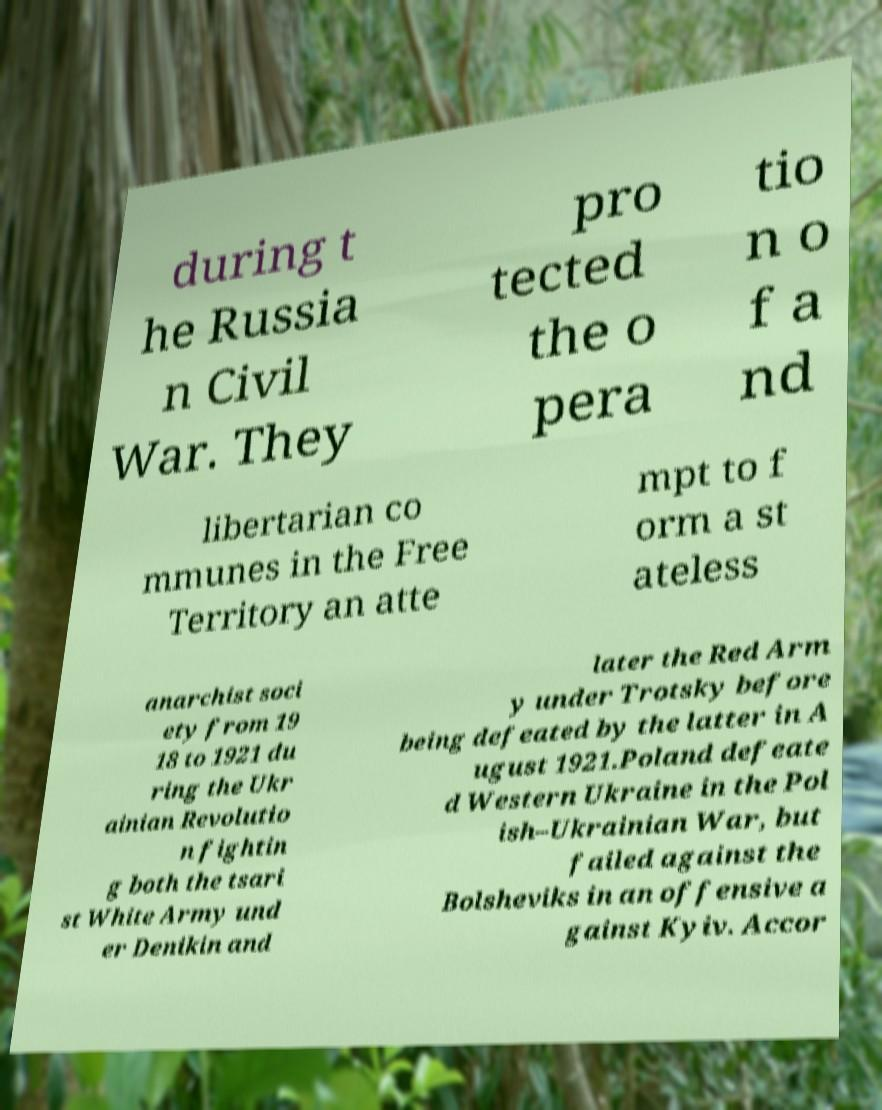I need the written content from this picture converted into text. Can you do that? during t he Russia n Civil War. They pro tected the o pera tio n o f a nd libertarian co mmunes in the Free Territory an atte mpt to f orm a st ateless anarchist soci ety from 19 18 to 1921 du ring the Ukr ainian Revolutio n fightin g both the tsari st White Army und er Denikin and later the Red Arm y under Trotsky before being defeated by the latter in A ugust 1921.Poland defeate d Western Ukraine in the Pol ish–Ukrainian War, but failed against the Bolsheviks in an offensive a gainst Kyiv. Accor 